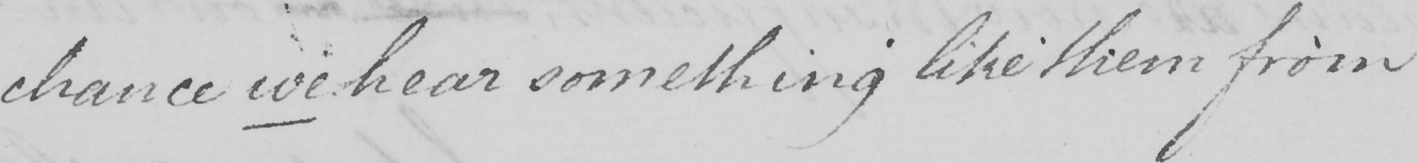What text is written in this handwritten line? chance we hear something like them from 